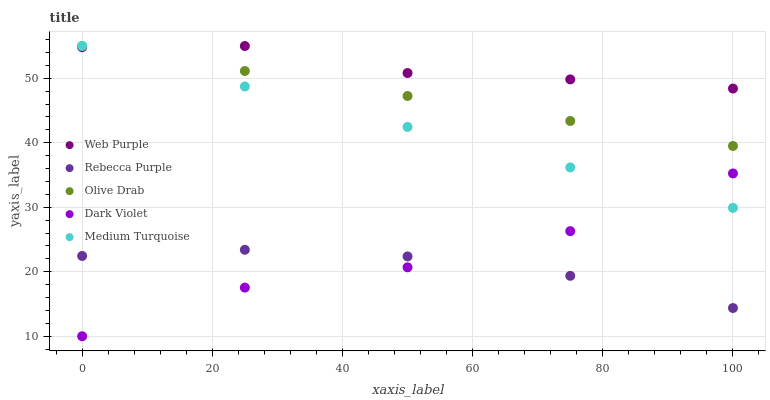Does Rebecca Purple have the minimum area under the curve?
Answer yes or no. Yes. Does Web Purple have the maximum area under the curve?
Answer yes or no. Yes. Does Dark Violet have the minimum area under the curve?
Answer yes or no. No. Does Dark Violet have the maximum area under the curve?
Answer yes or no. No. Is Olive Drab the smoothest?
Answer yes or no. Yes. Is Dark Violet the roughest?
Answer yes or no. Yes. Is Rebecca Purple the smoothest?
Answer yes or no. No. Is Rebecca Purple the roughest?
Answer yes or no. No. Does Dark Violet have the lowest value?
Answer yes or no. Yes. Does Rebecca Purple have the lowest value?
Answer yes or no. No. Does Medium Turquoise have the highest value?
Answer yes or no. Yes. Does Dark Violet have the highest value?
Answer yes or no. No. Is Rebecca Purple less than Web Purple?
Answer yes or no. Yes. Is Web Purple greater than Rebecca Purple?
Answer yes or no. Yes. Does Dark Violet intersect Medium Turquoise?
Answer yes or no. Yes. Is Dark Violet less than Medium Turquoise?
Answer yes or no. No. Is Dark Violet greater than Medium Turquoise?
Answer yes or no. No. Does Rebecca Purple intersect Web Purple?
Answer yes or no. No. 